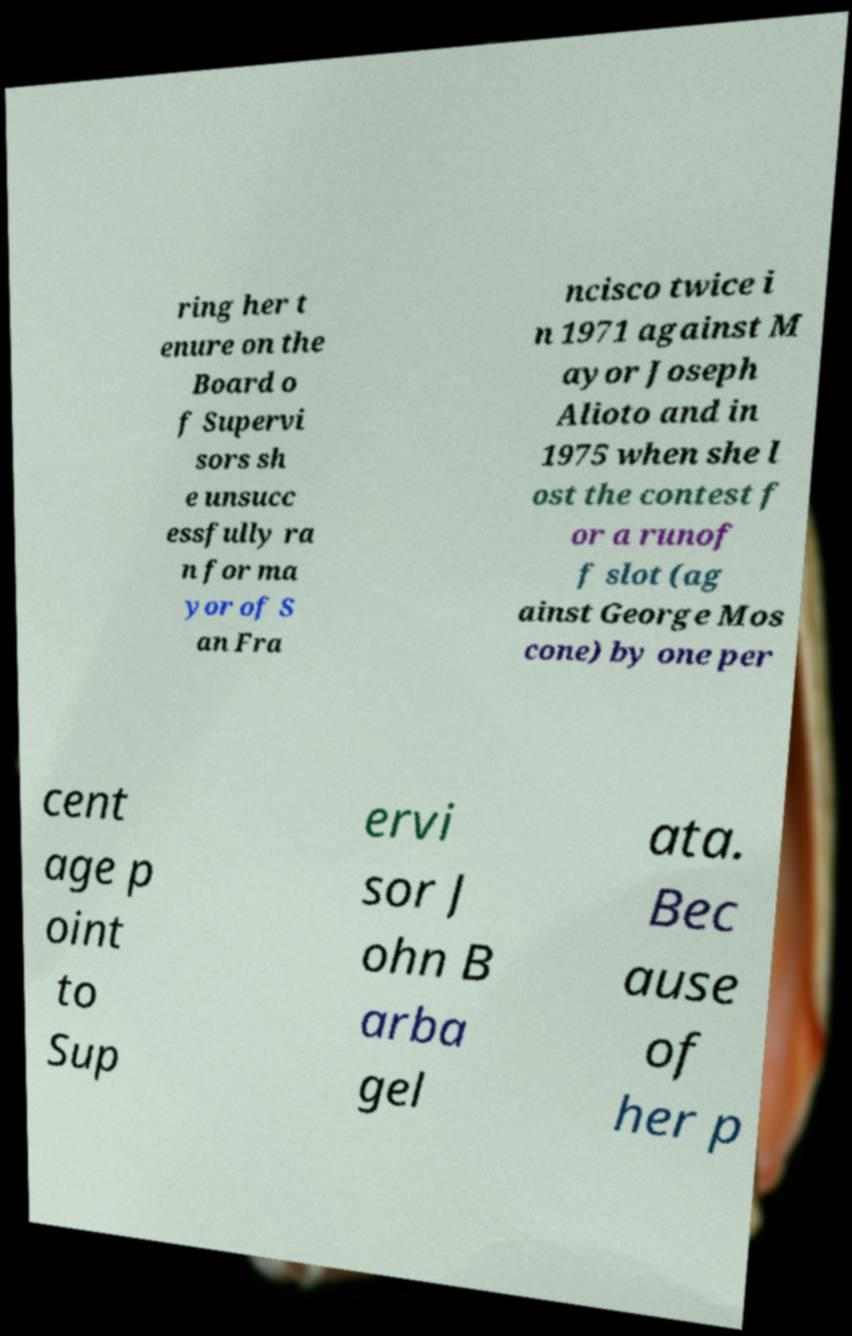I need the written content from this picture converted into text. Can you do that? ring her t enure on the Board o f Supervi sors sh e unsucc essfully ra n for ma yor of S an Fra ncisco twice i n 1971 against M ayor Joseph Alioto and in 1975 when she l ost the contest f or a runof f slot (ag ainst George Mos cone) by one per cent age p oint to Sup ervi sor J ohn B arba gel ata. Bec ause of her p 